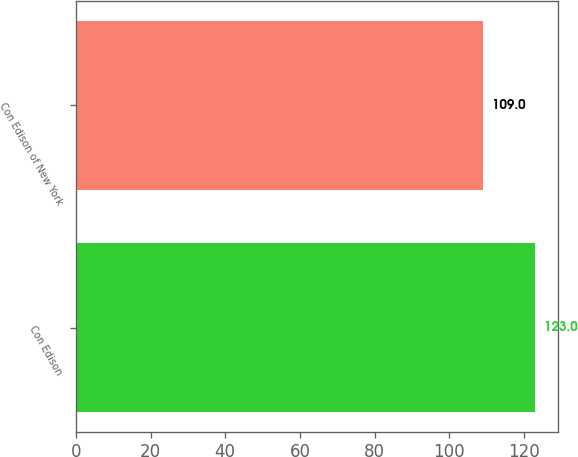<chart> <loc_0><loc_0><loc_500><loc_500><bar_chart><fcel>Con Edison<fcel>Con Edison of New York<nl><fcel>123<fcel>109<nl></chart> 